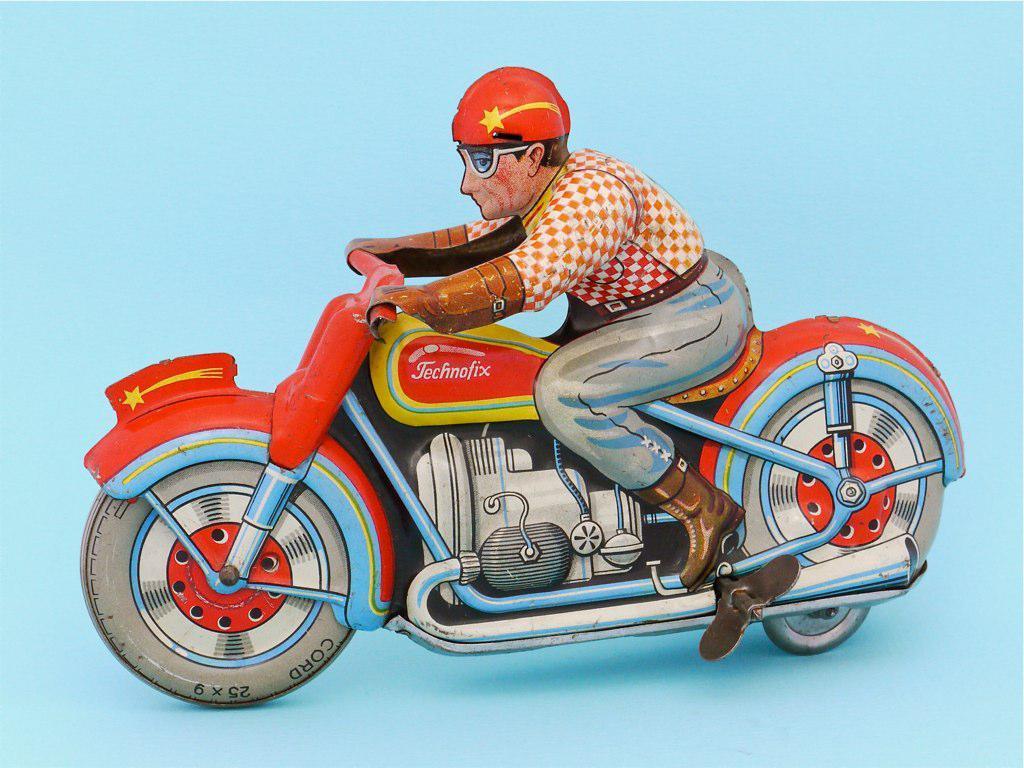In one or two sentences, can you explain what this image depicts? This is a picture of a 3d drawing of a person riding a motorbike. 